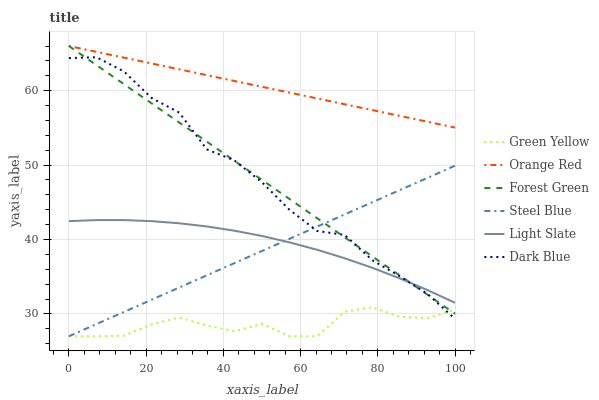Does Green Yellow have the minimum area under the curve?
Answer yes or no. Yes. Does Orange Red have the maximum area under the curve?
Answer yes or no. Yes. Does Steel Blue have the minimum area under the curve?
Answer yes or no. No. Does Steel Blue have the maximum area under the curve?
Answer yes or no. No. Is Orange Red the smoothest?
Answer yes or no. Yes. Is Dark Blue the roughest?
Answer yes or no. Yes. Is Steel Blue the smoothest?
Answer yes or no. No. Is Steel Blue the roughest?
Answer yes or no. No. Does Steel Blue have the lowest value?
Answer yes or no. Yes. Does Dark Blue have the lowest value?
Answer yes or no. No. Does Orange Red have the highest value?
Answer yes or no. Yes. Does Steel Blue have the highest value?
Answer yes or no. No. Is Light Slate less than Orange Red?
Answer yes or no. Yes. Is Orange Red greater than Light Slate?
Answer yes or no. Yes. Does Light Slate intersect Forest Green?
Answer yes or no. Yes. Is Light Slate less than Forest Green?
Answer yes or no. No. Is Light Slate greater than Forest Green?
Answer yes or no. No. Does Light Slate intersect Orange Red?
Answer yes or no. No. 